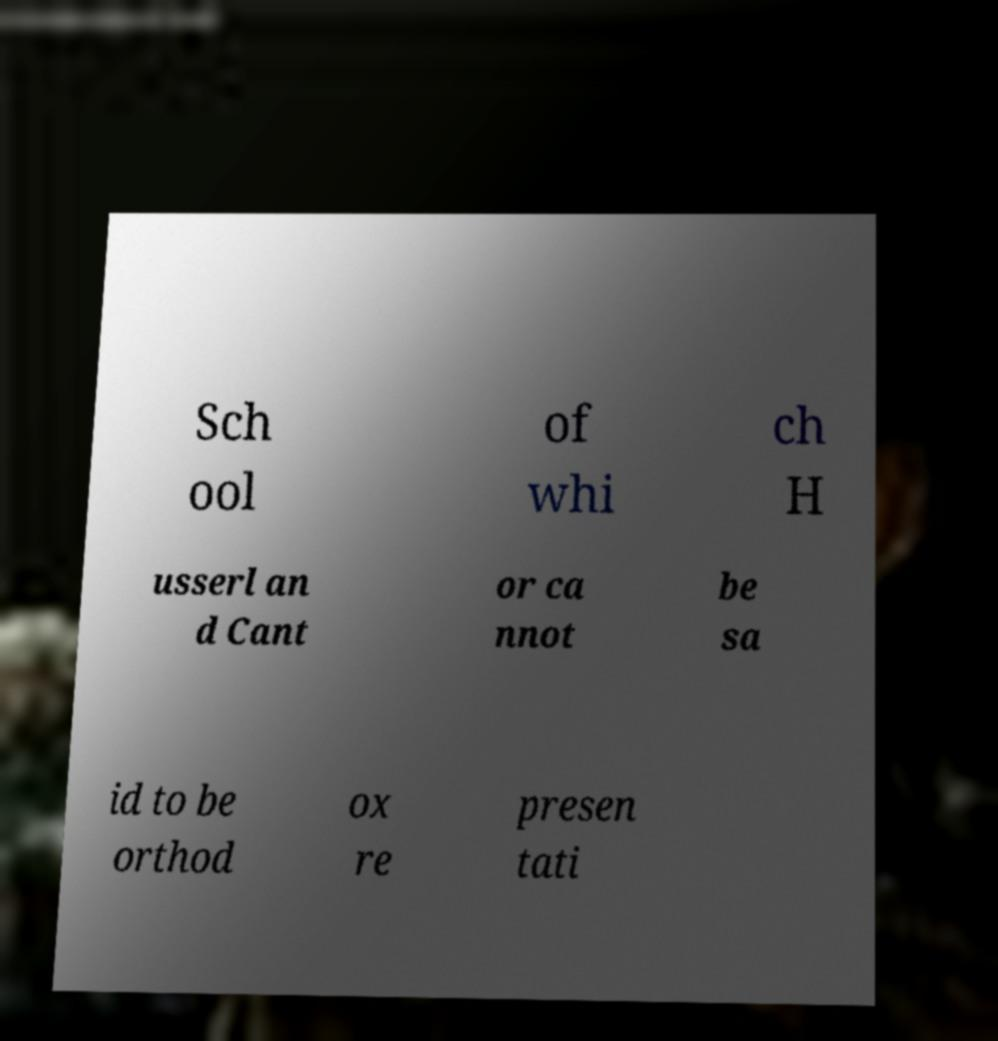Please identify and transcribe the text found in this image. Sch ool of whi ch H usserl an d Cant or ca nnot be sa id to be orthod ox re presen tati 